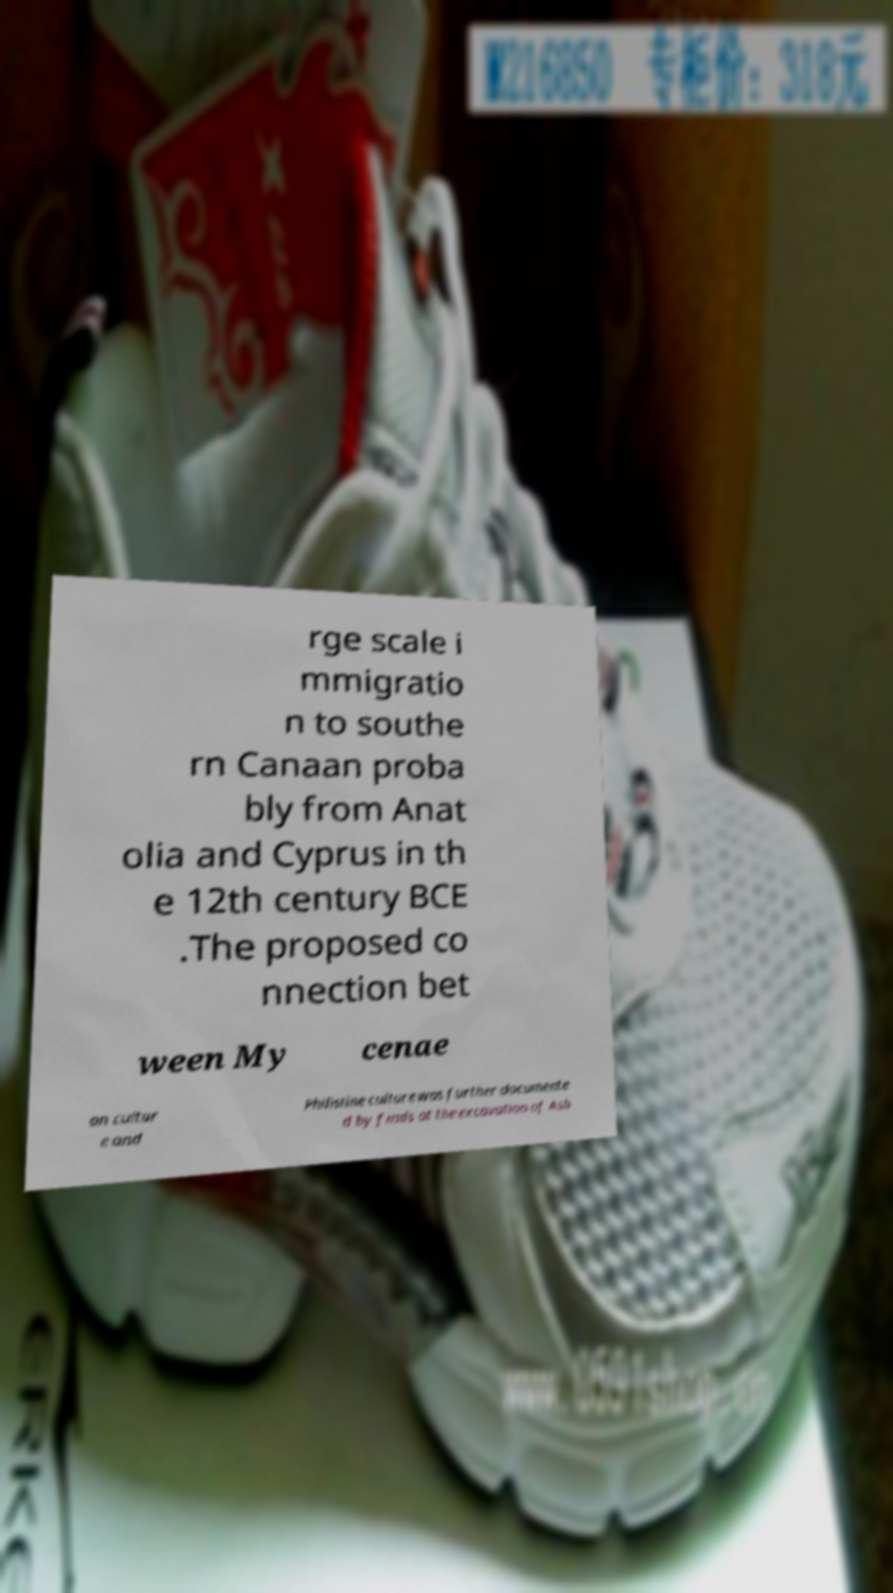Can you accurately transcribe the text from the provided image for me? rge scale i mmigratio n to southe rn Canaan proba bly from Anat olia and Cyprus in th e 12th century BCE .The proposed co nnection bet ween My cenae an cultur e and Philistine culture was further documente d by finds at the excavation of Ash 